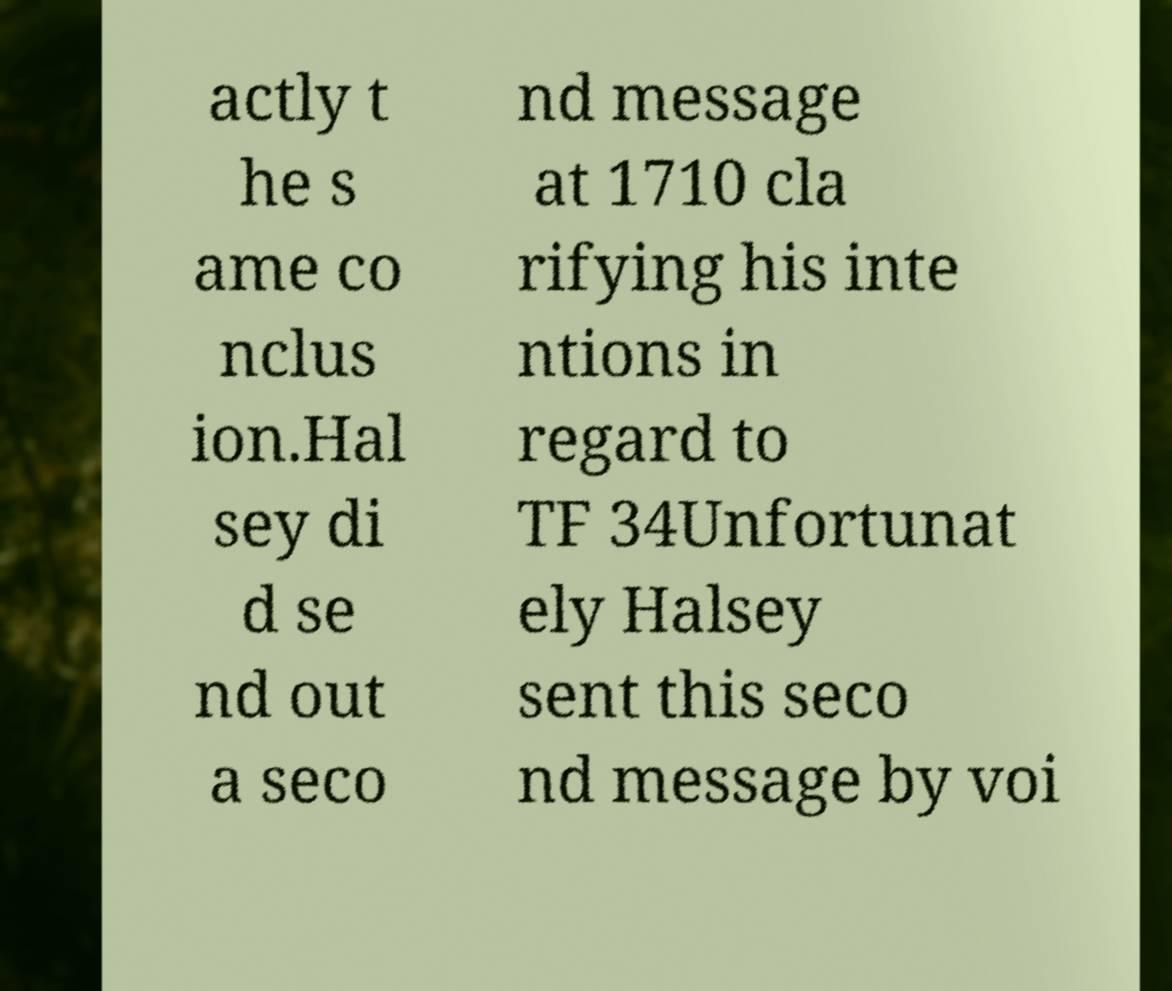Could you assist in decoding the text presented in this image and type it out clearly? actly t he s ame co nclus ion.Hal sey di d se nd out a seco nd message at 1710 cla rifying his inte ntions in regard to TF 34Unfortunat ely Halsey sent this seco nd message by voi 